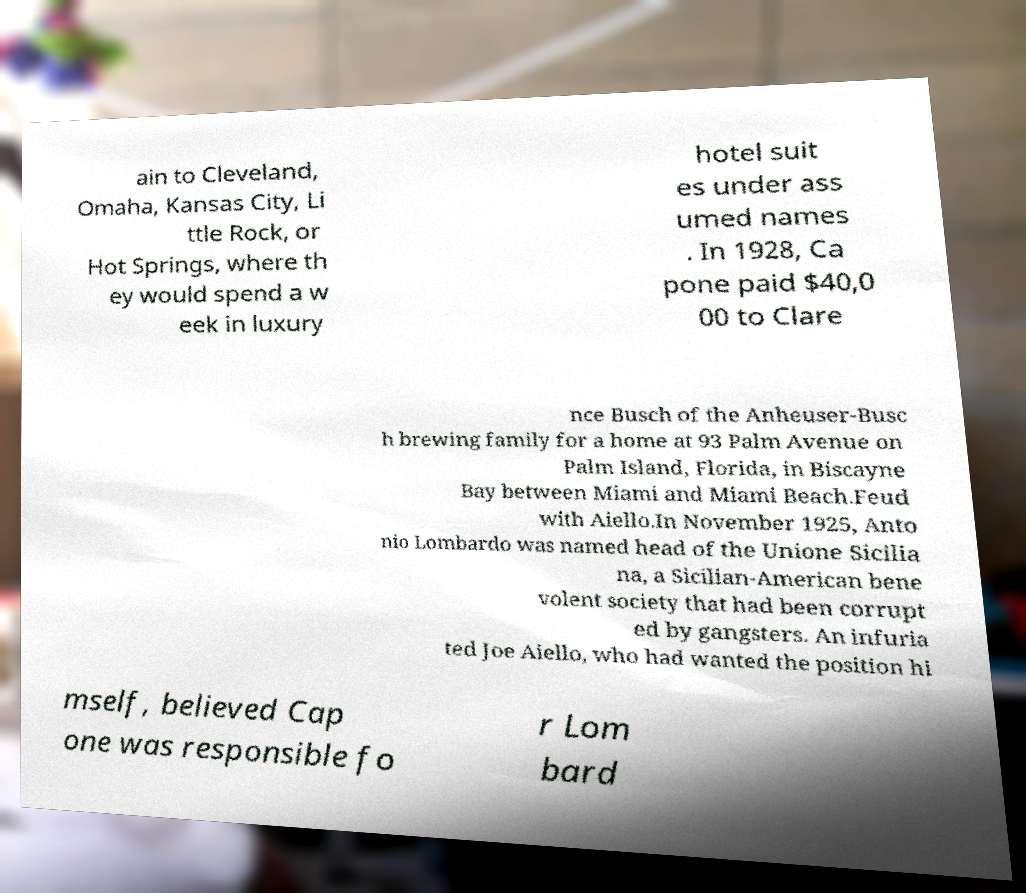Please identify and transcribe the text found in this image. ain to Cleveland, Omaha, Kansas City, Li ttle Rock, or Hot Springs, where th ey would spend a w eek in luxury hotel suit es under ass umed names . In 1928, Ca pone paid $40,0 00 to Clare nce Busch of the Anheuser-Busc h brewing family for a home at 93 Palm Avenue on Palm Island, Florida, in Biscayne Bay between Miami and Miami Beach.Feud with Aiello.In November 1925, Anto nio Lombardo was named head of the Unione Sicilia na, a Sicilian-American bene volent society that had been corrupt ed by gangsters. An infuria ted Joe Aiello, who had wanted the position hi mself, believed Cap one was responsible fo r Lom bard 